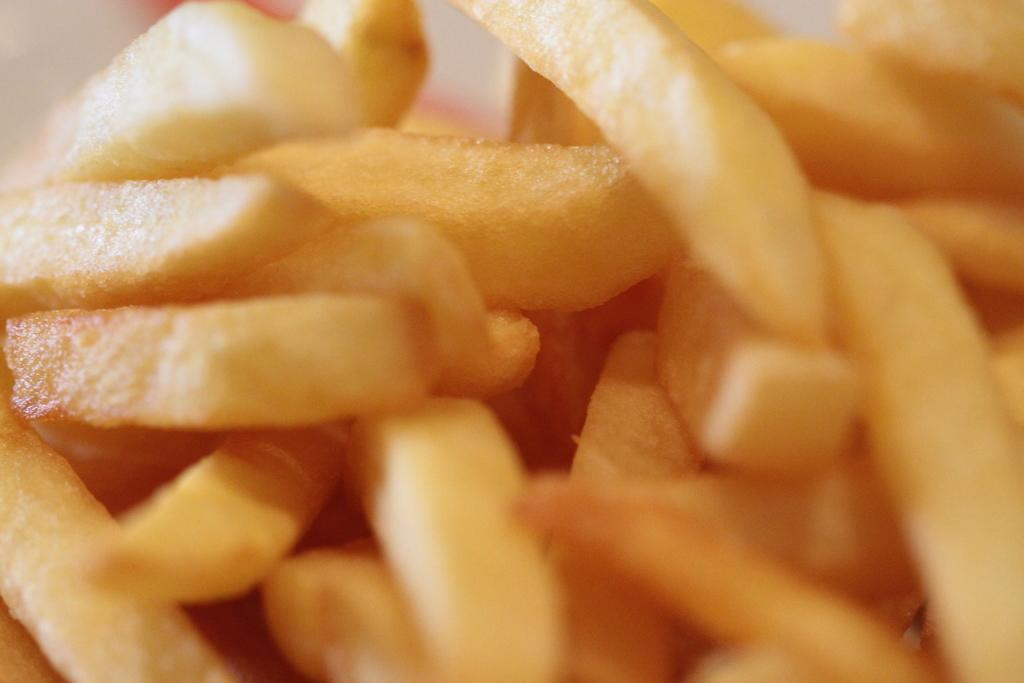What type of food is arranged in the image? There are potato chips arranged in the image. What color is the background of the image? The background of the image is white. What type of facial expression does the dad have in the image? There is no dad or face present in the image; it only features potato chips arranged on a white background. 